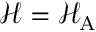Convert formula to latex. <formula><loc_0><loc_0><loc_500><loc_500>\mathcal { H } = \mathcal { H } _ { A }</formula> 